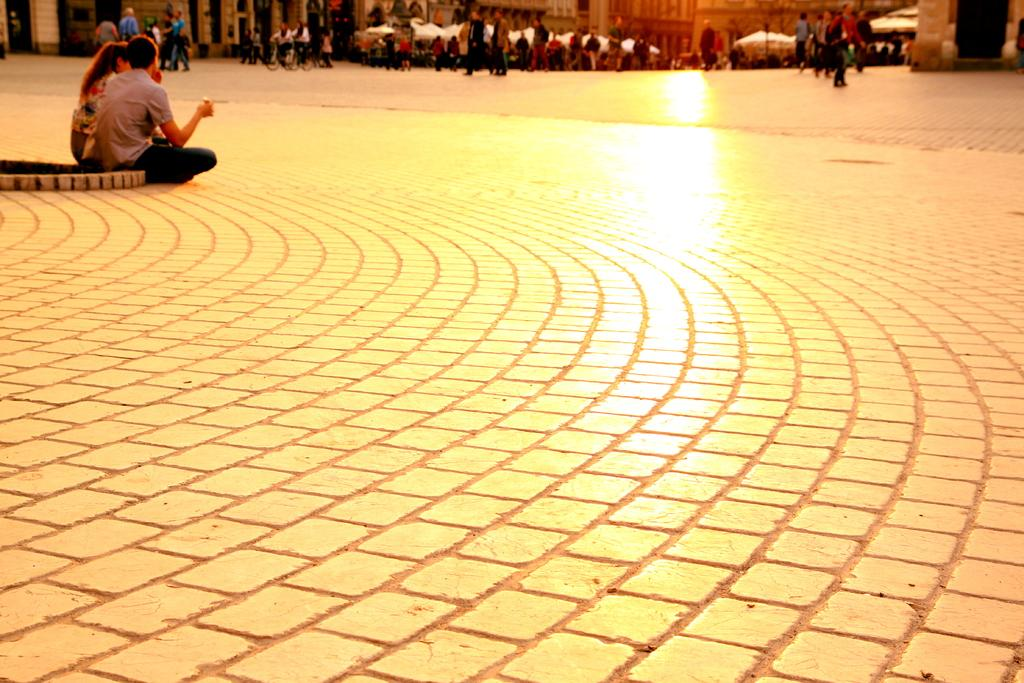What type of path is in the image? There is a walkway in the image. Can you describe the people in the image? A group of people is visible at the top of the image, with some sitting, standing, or walking. What structures can be seen in the image? There are buildings in the image. What type of vegetation is present in the image? Trees are present in the image. What type of powder is being used by the people in the image? There is no powder visible in the image; the people are simply sitting, standing, or walking. Can you see any steam coming from the buildings in the image? There is no steam visible in the image; only the buildings and trees are present. 